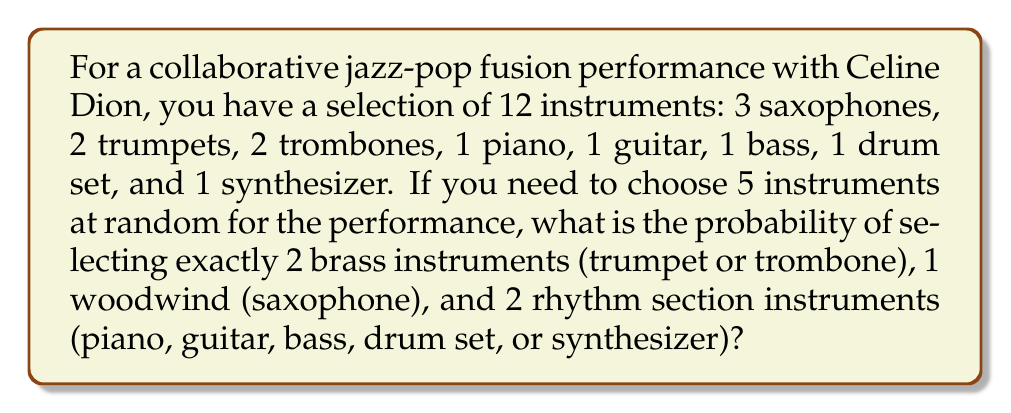Can you solve this math problem? Let's break this down step-by-step:

1) First, we need to calculate the number of ways to select 2 brass instruments out of 4:
   $${4 \choose 2} = \frac{4!}{2!(4-2)!} = 6$$

2) Next, we calculate the number of ways to select 1 saxophone out of 3:
   $${3 \choose 1} = 3$$

3) Then, we calculate the number of ways to select 2 rhythm section instruments out of 5:
   $${5 \choose 2} = \frac{5!}{2!(5-2)!} = 10$$

4) The total number of favorable outcomes is the product of these three selections:
   $$6 \times 3 \times 10 = 180$$

5) Now, we need to calculate the total number of ways to select 5 instruments out of 12:
   $${12 \choose 5} = \frac{12!}{5!(12-5)!} = 792$$

6) The probability is the number of favorable outcomes divided by the total number of possible outcomes:

   $$P = \frac{180}{792} = \frac{45}{198} \approx 0.2273$$
Answer: $\frac{45}{198}$ 